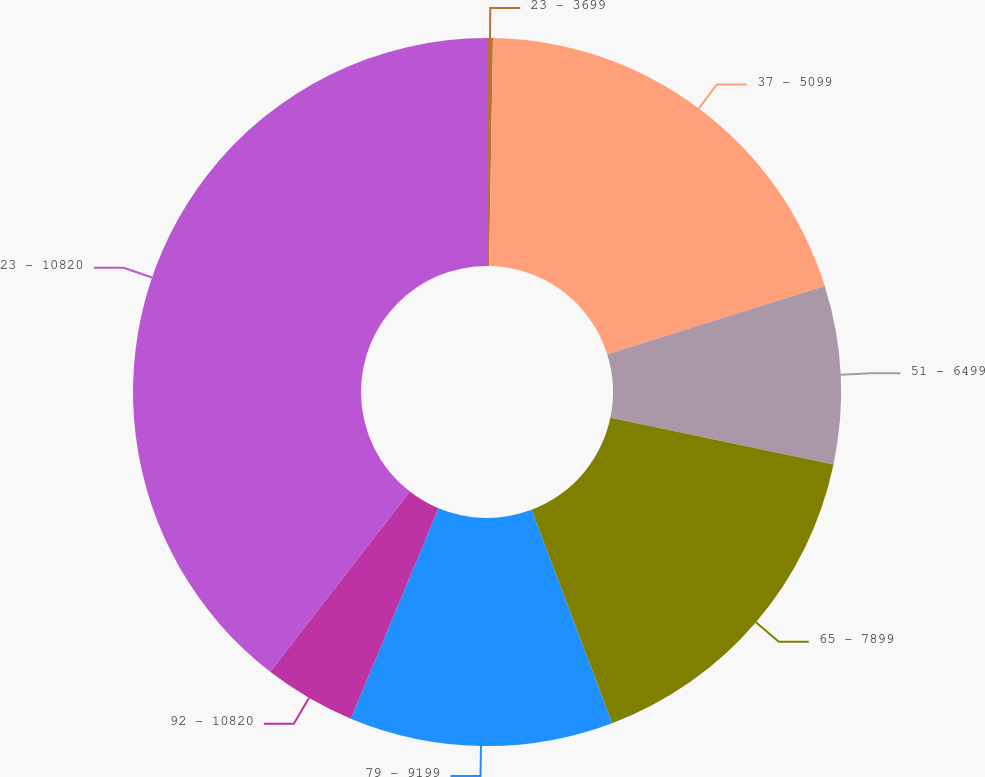<chart> <loc_0><loc_0><loc_500><loc_500><pie_chart><fcel>23 - 3699<fcel>37 - 5099<fcel>51 - 6499<fcel>65 - 7899<fcel>79 - 9199<fcel>92 - 10820<fcel>23 - 10820<nl><fcel>0.27%<fcel>19.89%<fcel>8.12%<fcel>15.97%<fcel>12.04%<fcel>4.2%<fcel>39.51%<nl></chart> 